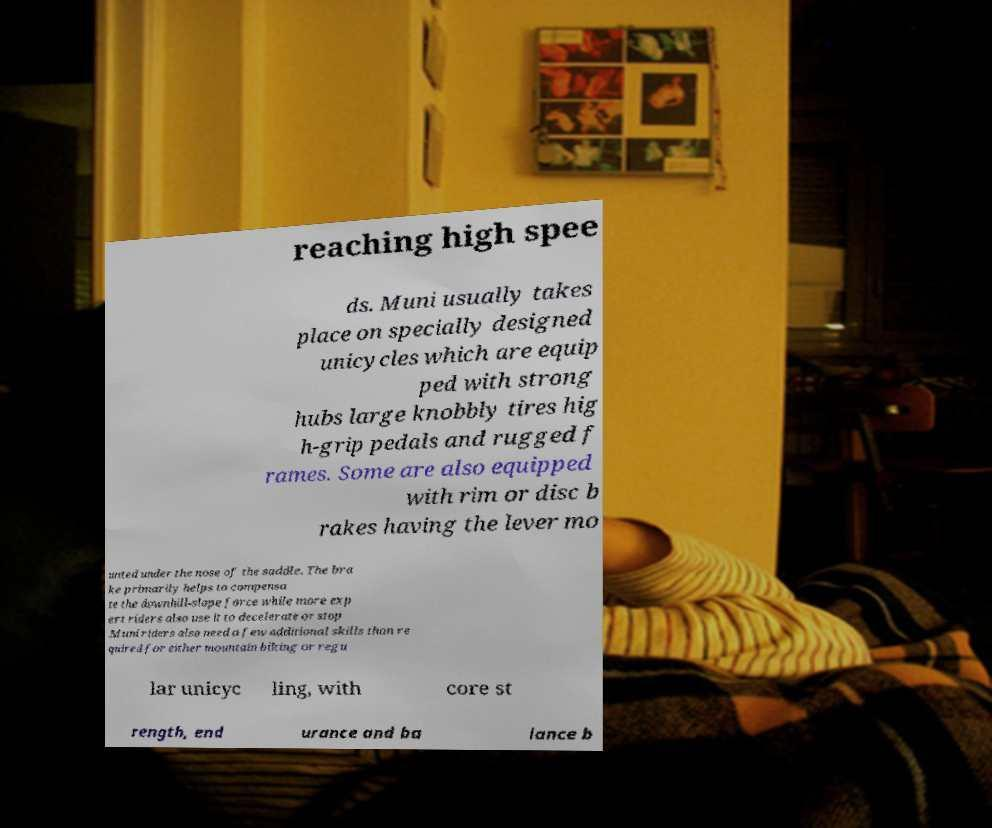Can you read and provide the text displayed in the image?This photo seems to have some interesting text. Can you extract and type it out for me? reaching high spee ds. Muni usually takes place on specially designed unicycles which are equip ped with strong hubs large knobbly tires hig h-grip pedals and rugged f rames. Some are also equipped with rim or disc b rakes having the lever mo unted under the nose of the saddle. The bra ke primarily helps to compensa te the downhill-slope force while more exp ert riders also use it to decelerate or stop .Muni riders also need a few additional skills than re quired for either mountain biking or regu lar unicyc ling, with core st rength, end urance and ba lance b 